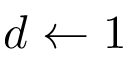Convert formula to latex. <formula><loc_0><loc_0><loc_500><loc_500>d \leftarrow 1</formula> 